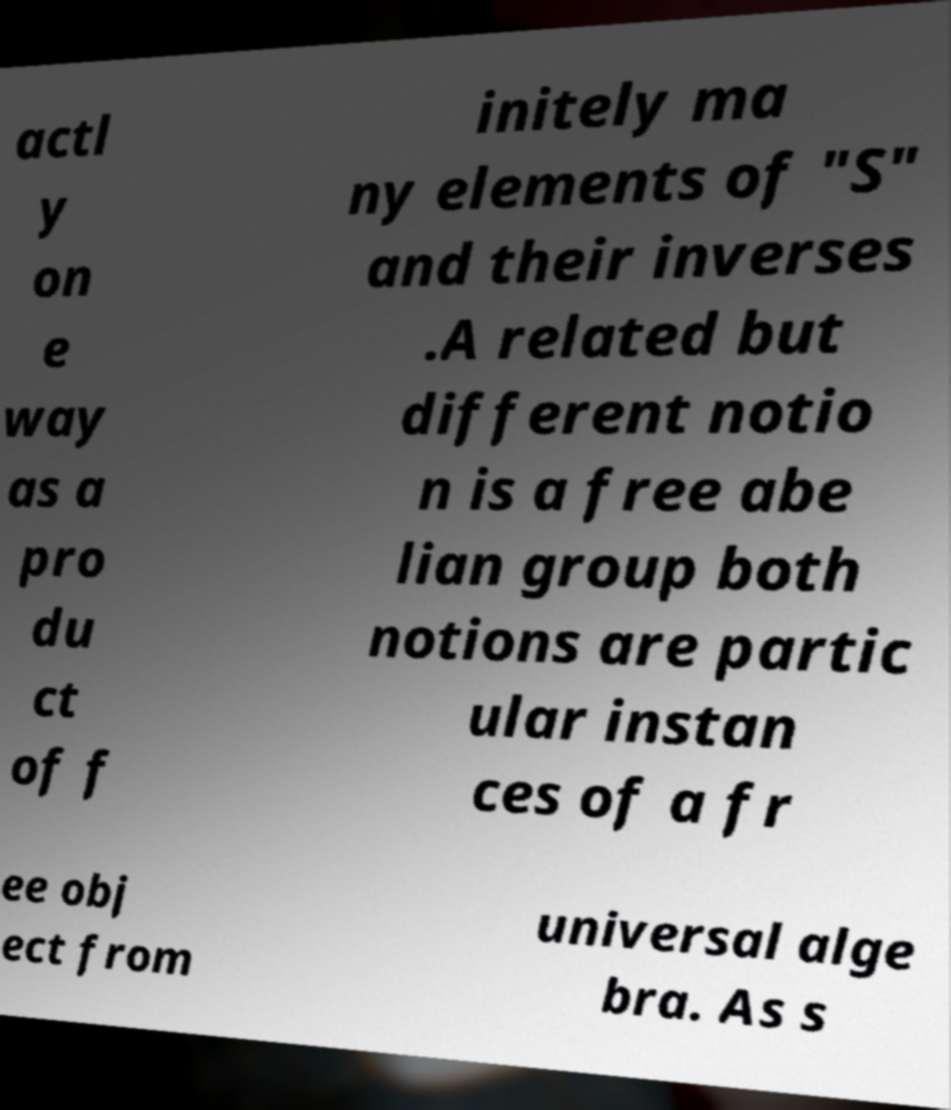There's text embedded in this image that I need extracted. Can you transcribe it verbatim? actl y on e way as a pro du ct of f initely ma ny elements of "S" and their inverses .A related but different notio n is a free abe lian group both notions are partic ular instan ces of a fr ee obj ect from universal alge bra. As s 